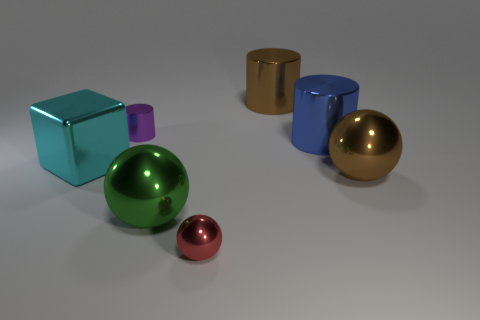What number of other objects are there of the same material as the purple object?
Ensure brevity in your answer.  6. What shape is the thing that is behind the big cyan metal thing and in front of the tiny cylinder?
Your response must be concise. Cylinder. There is a shiny object that is right of the blue metal cylinder; does it have the same size as the shiny cylinder that is to the left of the brown metallic cylinder?
Your answer should be compact. No. There is a large blue object that is the same material as the big cyan object; what is its shape?
Offer a terse response. Cylinder. Is there anything else that has the same shape as the red object?
Your answer should be very brief. Yes. There is a small shiny thing that is behind the big metallic thing that is to the left of the small object behind the green metallic sphere; what color is it?
Your response must be concise. Purple. Is the number of green metal objects that are to the left of the cyan metal object less than the number of big green shiny balls in front of the large green metal sphere?
Offer a terse response. No. Do the big cyan metal object and the big blue shiny object have the same shape?
Offer a very short reply. No. How many metallic cylinders have the same size as the green thing?
Provide a short and direct response. 2. Is the number of tiny cylinders in front of the big brown sphere less than the number of small red shiny objects?
Keep it short and to the point. Yes. 